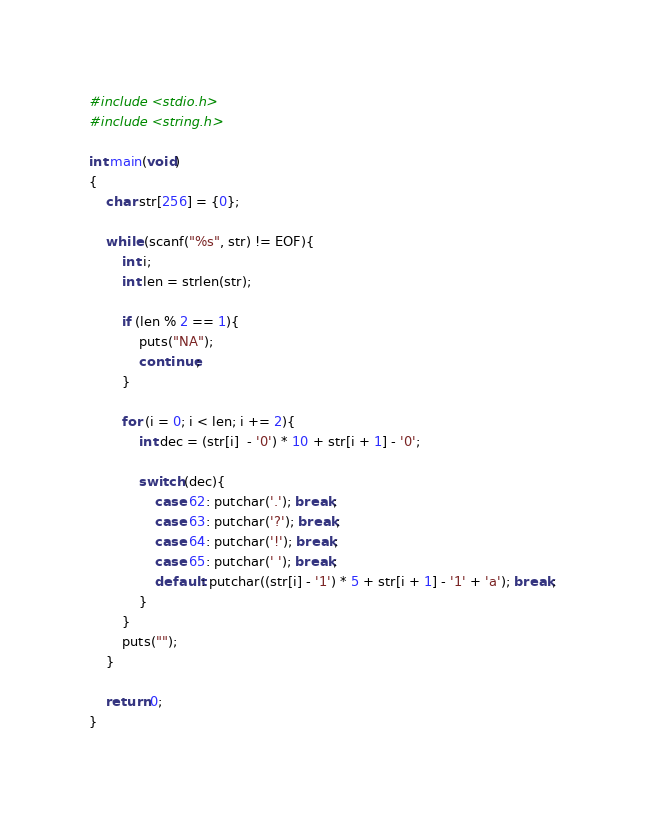Convert code to text. <code><loc_0><loc_0><loc_500><loc_500><_C_>#include <stdio.h>
#include <string.h>

int main(void)
{
    char str[256] = {0};

    while (scanf("%s", str) != EOF){
        int i;
        int len = strlen(str);

        if (len % 2 == 1){
            puts("NA");
            continue;
        }

        for (i = 0; i < len; i += 2){
            int dec = (str[i]  - '0') * 10 + str[i + 1] - '0';

            switch (dec){
                case 62: putchar('.'); break;
                case 63: putchar('?'); break;
                case 64: putchar('!'); break;
                case 65: putchar(' '); break;
                default: putchar((str[i] - '1') * 5 + str[i + 1] - '1' + 'a'); break;
            }
        }
        puts("");
    }

    return 0;
}</code> 